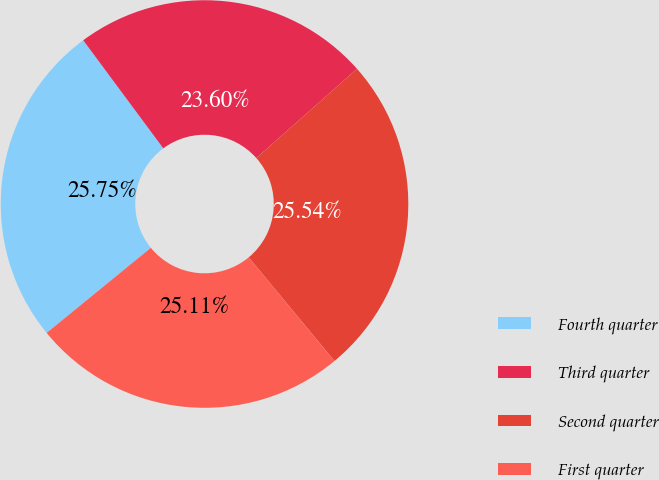Convert chart to OTSL. <chart><loc_0><loc_0><loc_500><loc_500><pie_chart><fcel>Fourth quarter<fcel>Third quarter<fcel>Second quarter<fcel>First quarter<nl><fcel>25.75%<fcel>23.6%<fcel>25.54%<fcel>25.11%<nl></chart> 